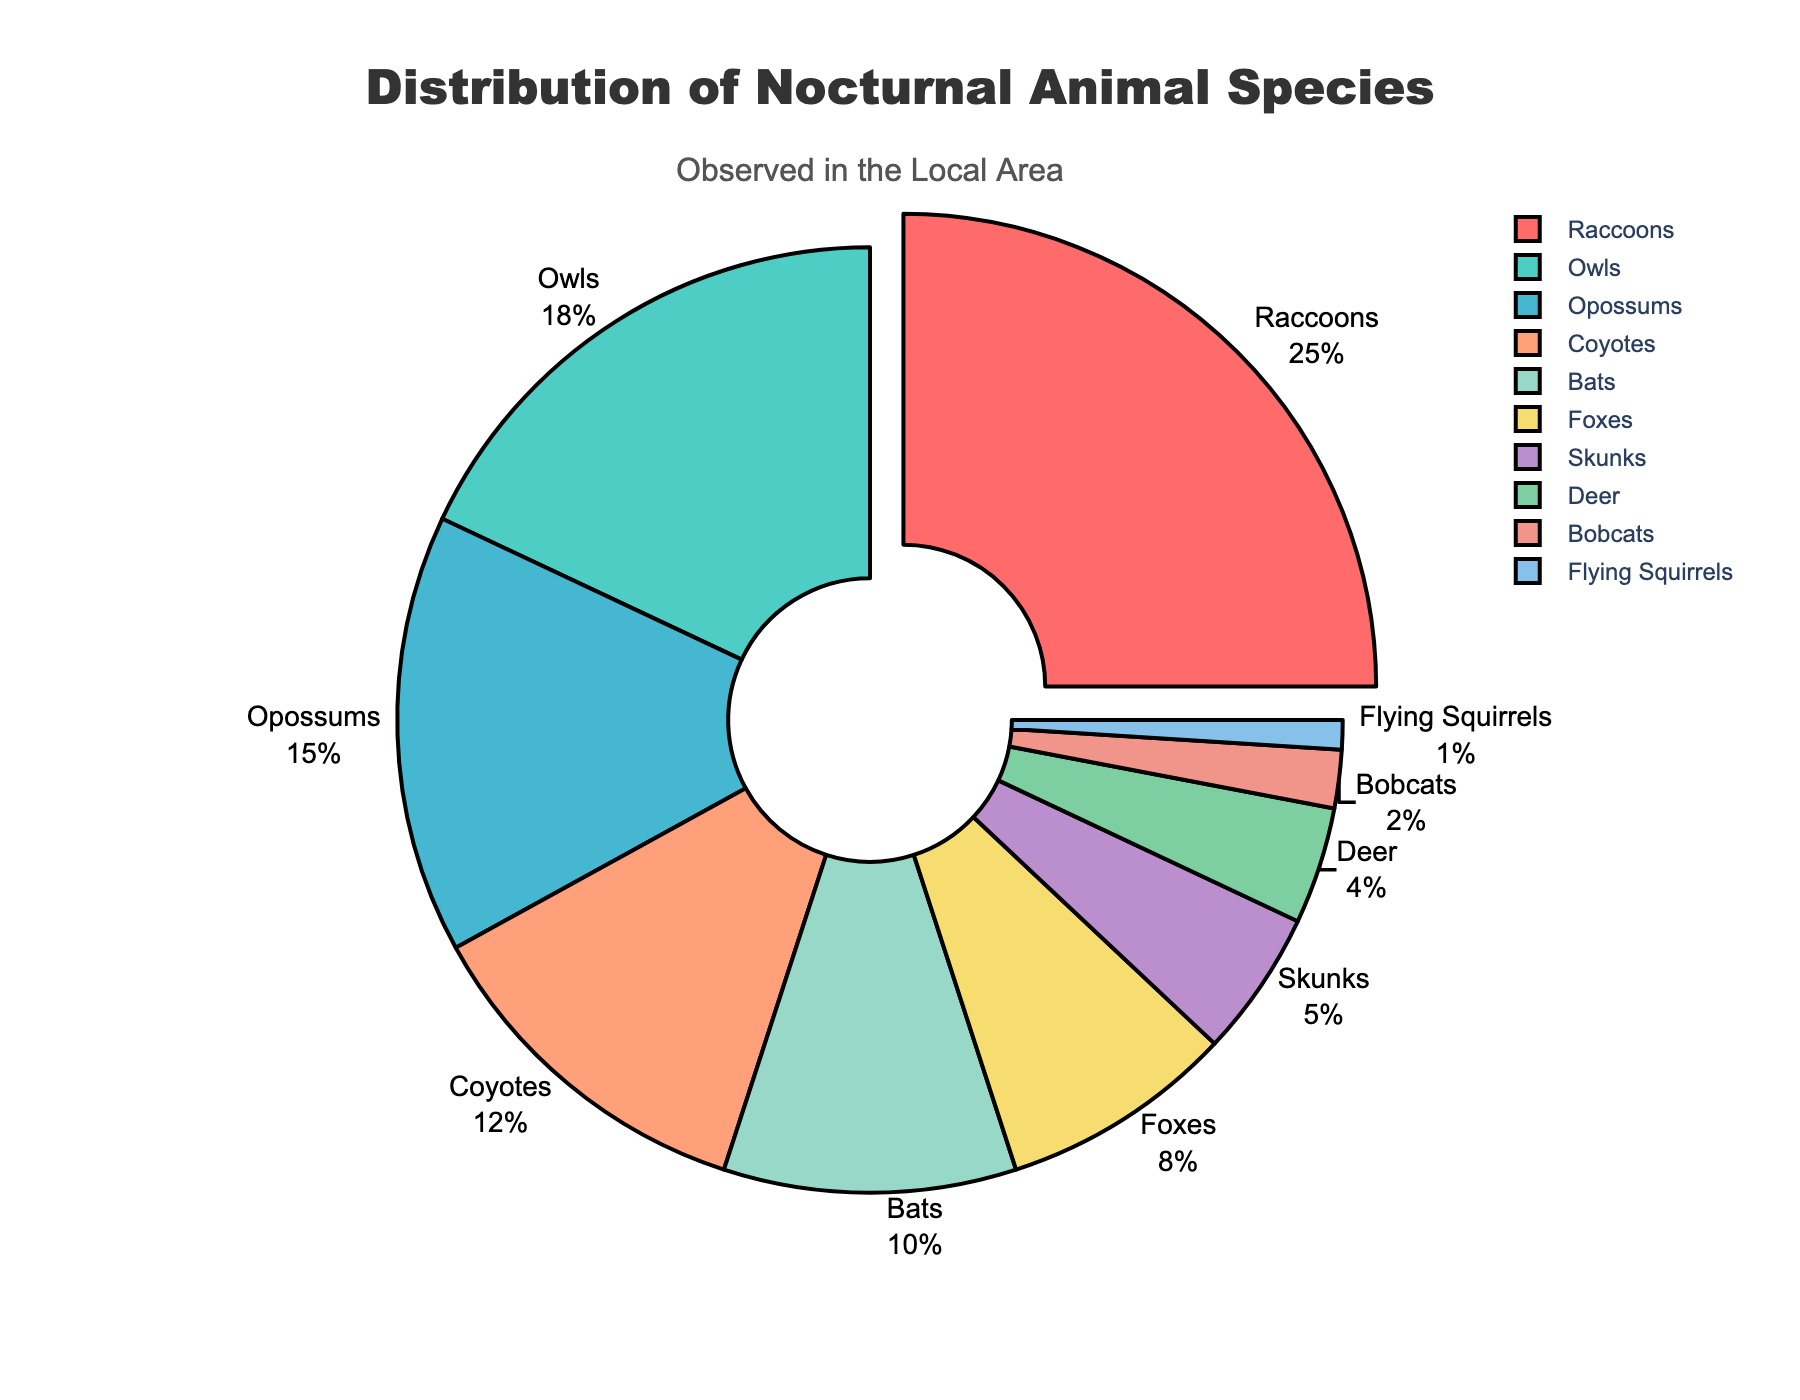What percentage of the observed nocturnal animals are coyotes? Locate "Coyotes" in the pie chart, then refer to the "Percentage" label associated with it.
Answer: 12% What is the sum of the percentages of raccoons and bats? Find the percentage of raccoons (25%) and bats (10%) in the chart, then add them together: 25% + 10% = 35%
Answer: 35% How does the percentage of deer compare to the percentage of foxes? Locate both "Deer" (4%) and "Foxes" (8%) in the pie chart, and compare their percentages.
Answer: Deer have a lower percentage than foxes What species has the smallest representation, and what is its percentage? Look for the species with the smallest percentage in the chart. In this case, it is "Flying Squirrels" at 1%.
Answer: Flying Squirrels, 1% What is the total percentage of animals that are either raccoons, owls, or opossums? Add the percentages for raccoons (25%), owls (18%), and opossums (15%): 25% + 18% + 15% = 58%
Answer: 58% Which species has the highest representation, and what additional visual cue highlights it? Identify the species with the highest percentage, which is "Raccoons" at 25%, and note the additional visual cue—a slight pull-out effect.
Answer: Raccoons, pull-out effect Are there more bobcats or flying squirrels observed, and by what percentage difference? Compare the percentages of bobcats (2%) and flying squirrels (1%) and calculate the difference: 2% - 1% = 1%
Answer: Bobcats, 1% What is the combined percentage of coyotes, bats, and foxes? Add the percentages for coyotes (12%), bats (10%), and foxes (8%): 12% + 10% + 8% = 30%
Answer: 30% Which species groups have percentages within 5% of each other? Compare the percentages of different species to identify groups that differ by no more than 5%. Examples include coyotes (12%) and bats (10%), and foxes (8%) and skunks (5%).
Answer: Coyotes and Bats; Foxes and Skunks What can be inferred about the variability of the observed species' presence from the pie chart? Observe the percentages allocated to each species to understand the range of their representation. The largest group is raccoons at 25%, whereas the smallest is flying squirrels at 1%, indicating variability in species' presence.
Answer: Presence varies significantly 